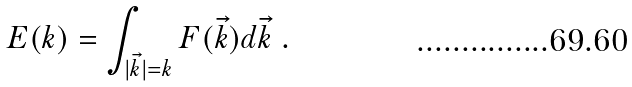Convert formula to latex. <formula><loc_0><loc_0><loc_500><loc_500>E ( k ) = \int _ { | \vec { k } | = k } F ( \vec { k } ) d \vec { k } \ .</formula> 